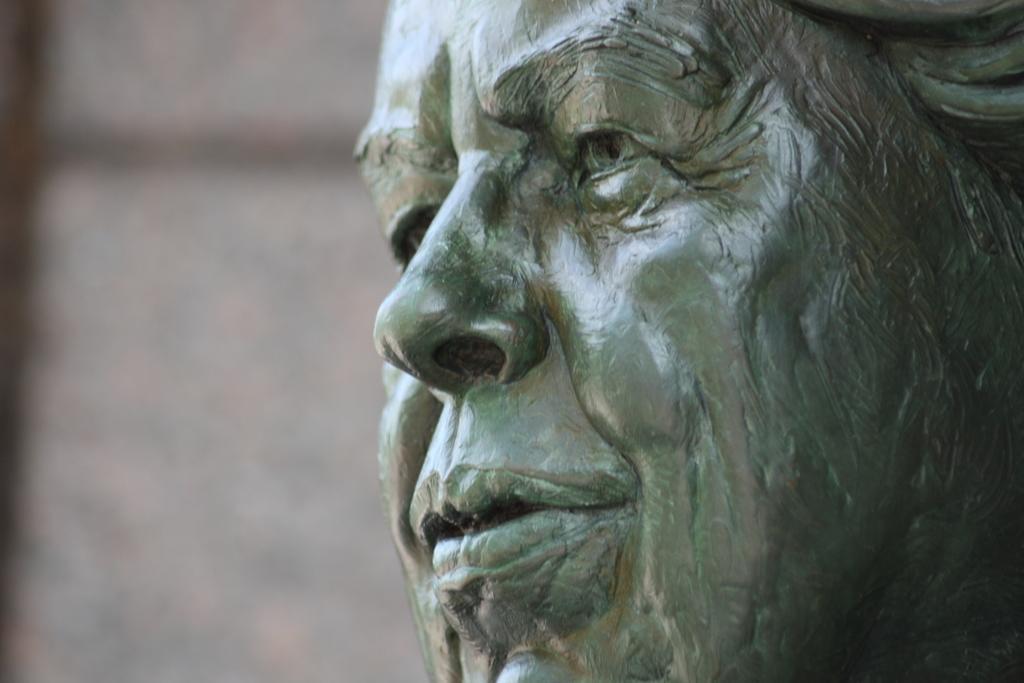Can you describe this image briefly? In this image, on the right side, we can see a statue of a person. On the left side, we can see white color and black color. 